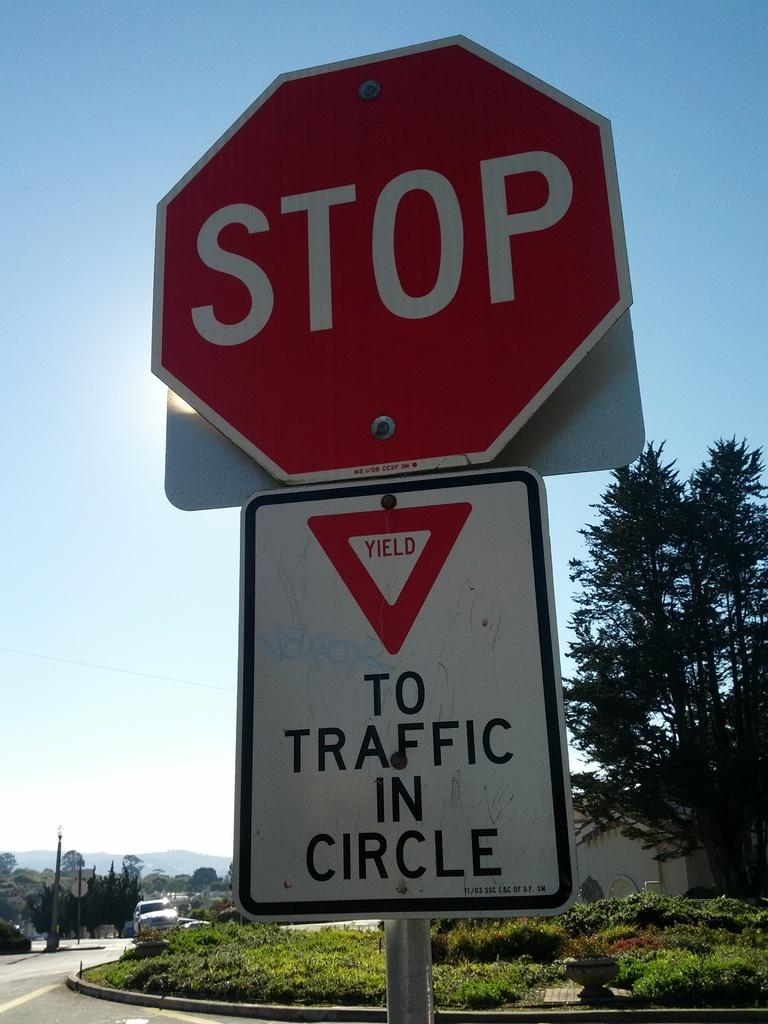<image>
Write a terse but informative summary of the picture. A red and white stop sign has another yield sign below it. 